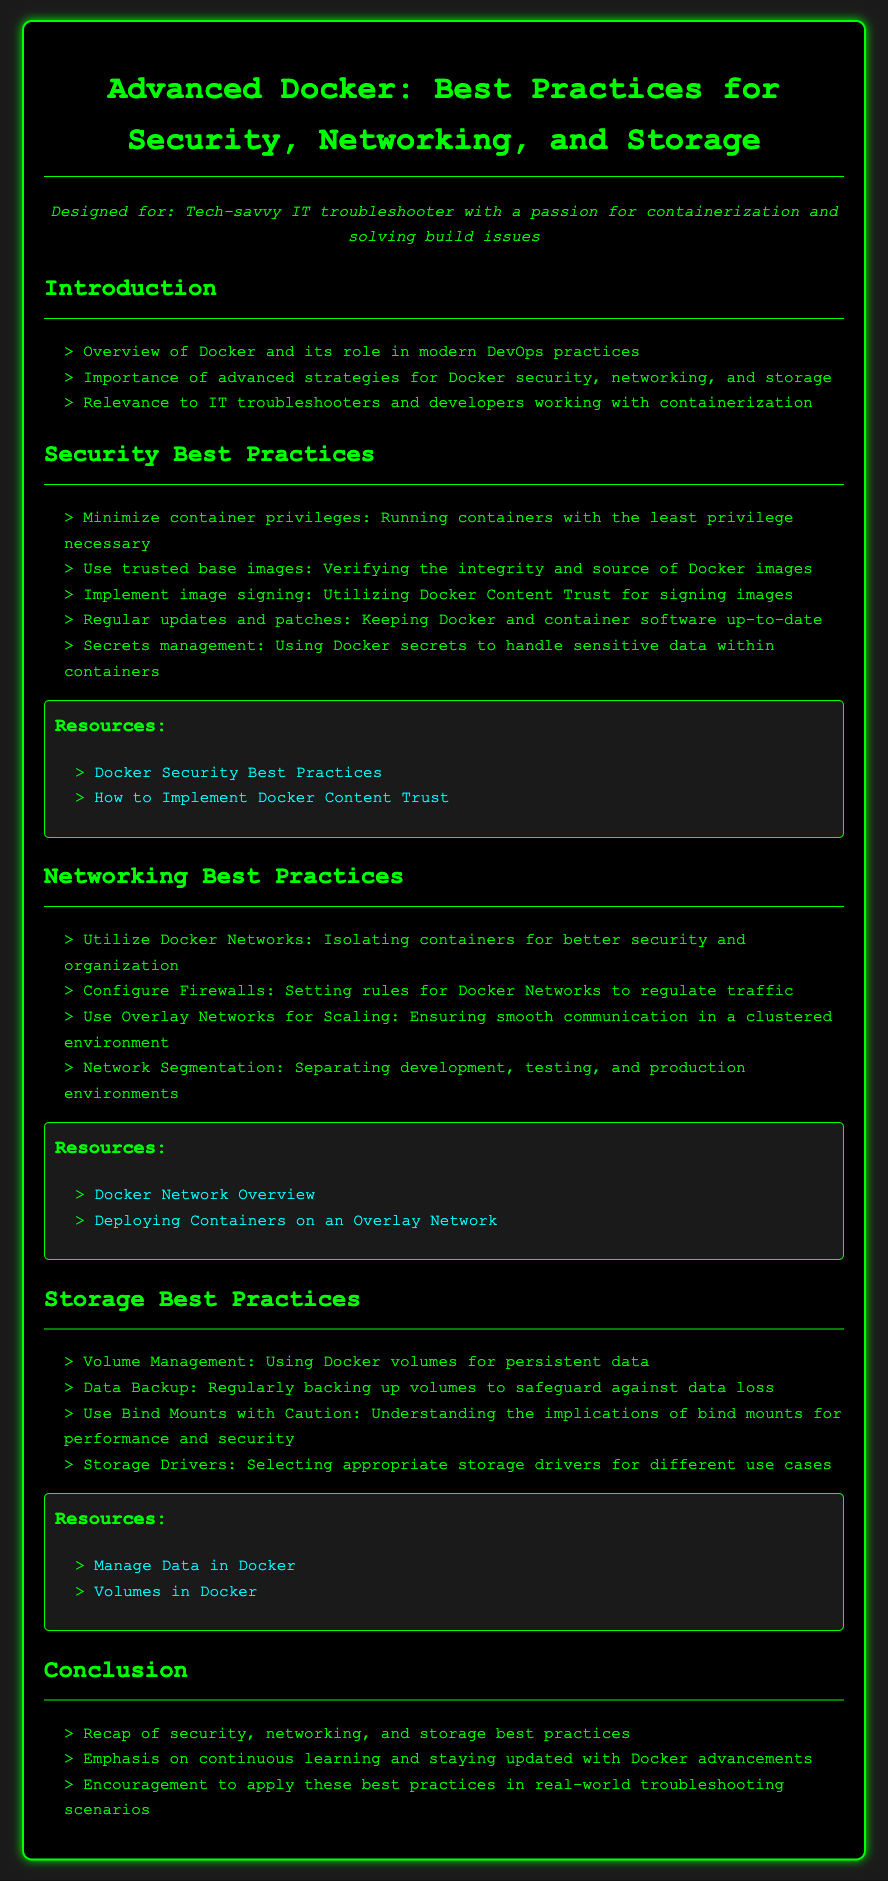What are the key areas of focus in the lesson plan? The lesson plan emphasizes security, networking, and storage best practices for Docker, highlighting strategies to improve container management.
Answer: Security, Networking, Storage How many resources are provided for security best practices? The document lists multiple resources under the security section to assist in implementing best practices.
Answer: 2 What should be used to handle sensitive data within containers? The lesson plan suggests a specific method for managing sensitive information securely within Docker containers.
Answer: Docker secrets What strategy is recommended for managing persistent data? The lesson plan highlights a specific approach for ensuring data persistence in containers, which is essential for certain applications.
Answer: Docker volumes What is emphasized in the conclusion regarding Docker advancements? The lesson plan encourages continuous engagement with Docker developments to maintain best practices and improve troubleshooting effectiveness.
Answer: Continuous learning 